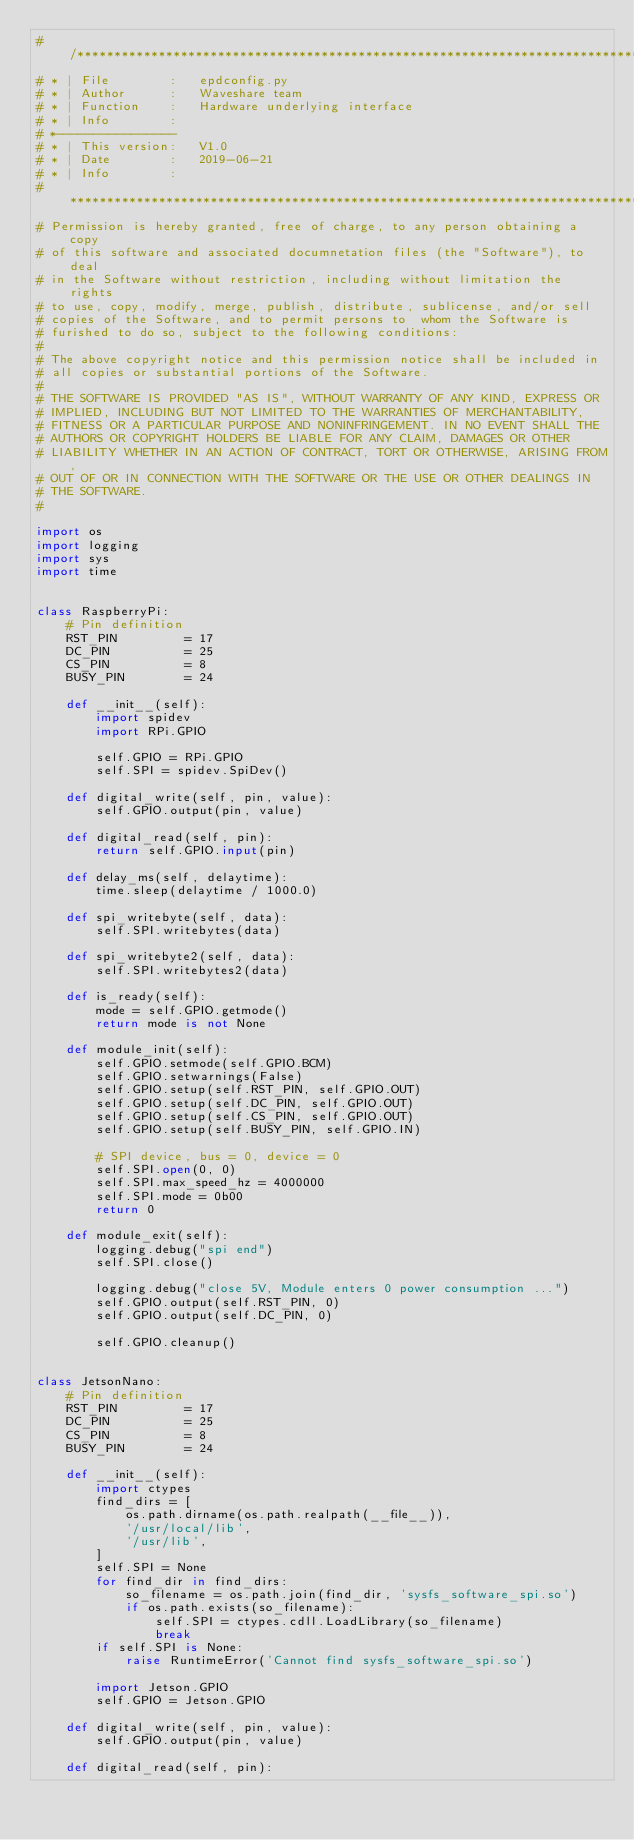<code> <loc_0><loc_0><loc_500><loc_500><_Python_># /*****************************************************************************
# * | File        :	  epdconfig.py
# * | Author      :   Waveshare team
# * | Function    :   Hardware underlying interface
# * | Info        :
# *----------------
# * | This version:   V1.0
# * | Date        :   2019-06-21
# * | Info        :   
# ******************************************************************************
# Permission is hereby granted, free of charge, to any person obtaining a copy
# of this software and associated documnetation files (the "Software"), to deal
# in the Software without restriction, including without limitation the rights
# to use, copy, modify, merge, publish, distribute, sublicense, and/or sell
# copies of the Software, and to permit persons to  whom the Software is
# furished to do so, subject to the following conditions:
#
# The above copyright notice and this permission notice shall be included in
# all copies or substantial portions of the Software.
#
# THE SOFTWARE IS PROVIDED "AS IS", WITHOUT WARRANTY OF ANY KIND, EXPRESS OR
# IMPLIED, INCLUDING BUT NOT LIMITED TO THE WARRANTIES OF MERCHANTABILITY,
# FITNESS OR A PARTICULAR PURPOSE AND NONINFRINGEMENT. IN NO EVENT SHALL THE
# AUTHORS OR COPYRIGHT HOLDERS BE LIABLE FOR ANY CLAIM, DAMAGES OR OTHER
# LIABILITY WHETHER IN AN ACTION OF CONTRACT, TORT OR OTHERWISE, ARISING FROM,
# OUT OF OR IN CONNECTION WITH THE SOFTWARE OR THE USE OR OTHER DEALINGS IN
# THE SOFTWARE.
#

import os
import logging
import sys
import time


class RaspberryPi:
    # Pin definition
    RST_PIN         = 17
    DC_PIN          = 25
    CS_PIN          = 8
    BUSY_PIN        = 24

    def __init__(self):
        import spidev
        import RPi.GPIO

        self.GPIO = RPi.GPIO
        self.SPI = spidev.SpiDev()

    def digital_write(self, pin, value):
        self.GPIO.output(pin, value)

    def digital_read(self, pin):
        return self.GPIO.input(pin)

    def delay_ms(self, delaytime):
        time.sleep(delaytime / 1000.0)

    def spi_writebyte(self, data):
        self.SPI.writebytes(data)

    def spi_writebyte2(self, data):
        self.SPI.writebytes2(data)
    
    def is_ready(self):
        mode = self.GPIO.getmode()
        return mode is not None

    def module_init(self):
        self.GPIO.setmode(self.GPIO.BCM)
        self.GPIO.setwarnings(False)
        self.GPIO.setup(self.RST_PIN, self.GPIO.OUT)
        self.GPIO.setup(self.DC_PIN, self.GPIO.OUT)
        self.GPIO.setup(self.CS_PIN, self.GPIO.OUT)
        self.GPIO.setup(self.BUSY_PIN, self.GPIO.IN)

        # SPI device, bus = 0, device = 0
        self.SPI.open(0, 0)
        self.SPI.max_speed_hz = 4000000
        self.SPI.mode = 0b00
        return 0

    def module_exit(self):
        logging.debug("spi end")
        self.SPI.close()

        logging.debug("close 5V, Module enters 0 power consumption ...")
        self.GPIO.output(self.RST_PIN, 0)
        self.GPIO.output(self.DC_PIN, 0)

        self.GPIO.cleanup()


class JetsonNano:
    # Pin definition
    RST_PIN         = 17
    DC_PIN          = 25
    CS_PIN          = 8
    BUSY_PIN        = 24

    def __init__(self):
        import ctypes
        find_dirs = [
            os.path.dirname(os.path.realpath(__file__)),
            '/usr/local/lib',
            '/usr/lib',
        ]
        self.SPI = None
        for find_dir in find_dirs:
            so_filename = os.path.join(find_dir, 'sysfs_software_spi.so')
            if os.path.exists(so_filename):
                self.SPI = ctypes.cdll.LoadLibrary(so_filename)
                break
        if self.SPI is None:
            raise RuntimeError('Cannot find sysfs_software_spi.so')

        import Jetson.GPIO
        self.GPIO = Jetson.GPIO

    def digital_write(self, pin, value):
        self.GPIO.output(pin, value)

    def digital_read(self, pin):</code> 